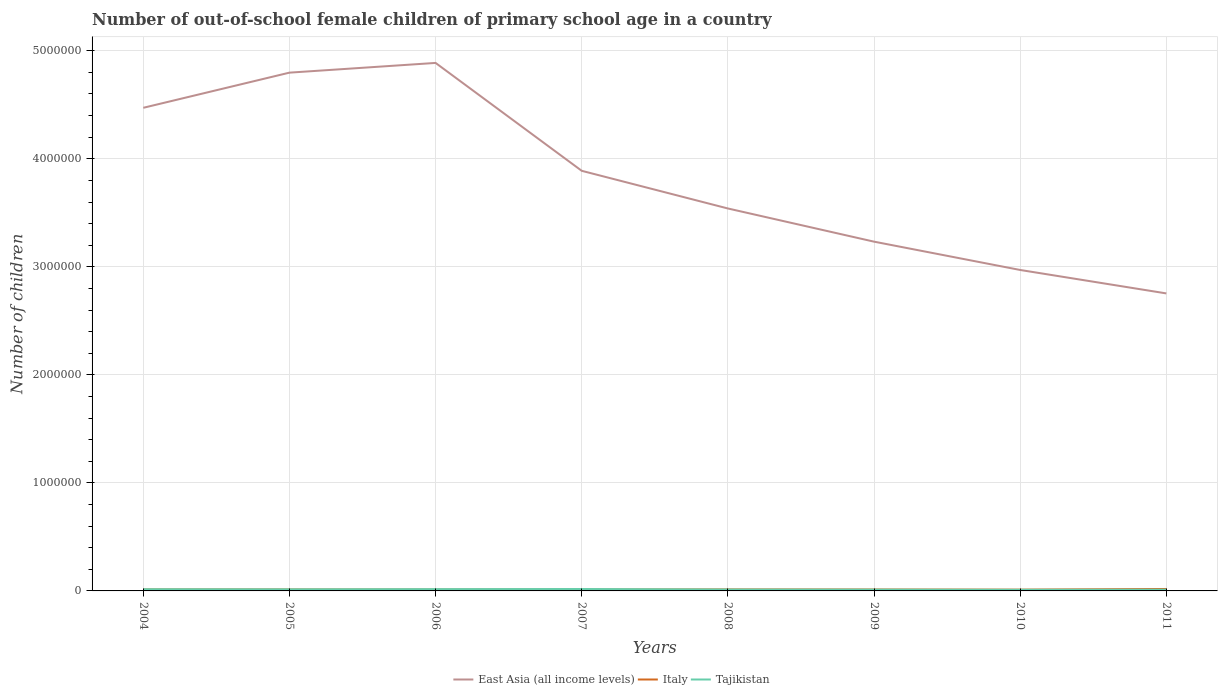How many different coloured lines are there?
Provide a short and direct response. 3. Does the line corresponding to Tajikistan intersect with the line corresponding to East Asia (all income levels)?
Your response must be concise. No. Is the number of lines equal to the number of legend labels?
Give a very brief answer. Yes. Across all years, what is the maximum number of out-of-school female children in Tajikistan?
Your answer should be very brief. 1.05e+04. What is the total number of out-of-school female children in Italy in the graph?
Give a very brief answer. 1078. What is the difference between the highest and the second highest number of out-of-school female children in Tajikistan?
Provide a short and direct response. 7159. Is the number of out-of-school female children in Italy strictly greater than the number of out-of-school female children in East Asia (all income levels) over the years?
Ensure brevity in your answer.  Yes. How many lines are there?
Your answer should be very brief. 3. How many years are there in the graph?
Your answer should be very brief. 8. What is the difference between two consecutive major ticks on the Y-axis?
Offer a very short reply. 1.00e+06. Are the values on the major ticks of Y-axis written in scientific E-notation?
Keep it short and to the point. No. Does the graph contain grids?
Provide a short and direct response. Yes. Where does the legend appear in the graph?
Provide a succinct answer. Bottom center. How many legend labels are there?
Your answer should be very brief. 3. What is the title of the graph?
Your answer should be compact. Number of out-of-school female children of primary school age in a country. What is the label or title of the X-axis?
Provide a succinct answer. Years. What is the label or title of the Y-axis?
Keep it short and to the point. Number of children. What is the Number of children of East Asia (all income levels) in 2004?
Make the answer very short. 4.47e+06. What is the Number of children of Italy in 2004?
Make the answer very short. 1.40e+04. What is the Number of children of Tajikistan in 2004?
Your answer should be very brief. 1.56e+04. What is the Number of children of East Asia (all income levels) in 2005?
Offer a terse response. 4.80e+06. What is the Number of children in Italy in 2005?
Offer a terse response. 1.37e+04. What is the Number of children of Tajikistan in 2005?
Provide a succinct answer. 1.46e+04. What is the Number of children of East Asia (all income levels) in 2006?
Your answer should be compact. 4.89e+06. What is the Number of children in Italy in 2006?
Keep it short and to the point. 1.27e+04. What is the Number of children in Tajikistan in 2006?
Make the answer very short. 1.64e+04. What is the Number of children of East Asia (all income levels) in 2007?
Offer a very short reply. 3.89e+06. What is the Number of children in Italy in 2007?
Offer a terse response. 1.31e+04. What is the Number of children in Tajikistan in 2007?
Make the answer very short. 1.77e+04. What is the Number of children of East Asia (all income levels) in 2008?
Offer a terse response. 3.54e+06. What is the Number of children of Italy in 2008?
Keep it short and to the point. 1.41e+04. What is the Number of children of Tajikistan in 2008?
Make the answer very short. 1.28e+04. What is the Number of children of East Asia (all income levels) in 2009?
Offer a terse response. 3.23e+06. What is the Number of children in Italy in 2009?
Make the answer very short. 1.33e+04. What is the Number of children of Tajikistan in 2009?
Your answer should be very brief. 1.19e+04. What is the Number of children of East Asia (all income levels) in 2010?
Your answer should be very brief. 2.97e+06. What is the Number of children of Italy in 2010?
Offer a terse response. 1.20e+04. What is the Number of children in Tajikistan in 2010?
Provide a short and direct response. 1.05e+04. What is the Number of children in East Asia (all income levels) in 2011?
Make the answer very short. 2.75e+06. What is the Number of children in Italy in 2011?
Your response must be concise. 1.79e+04. What is the Number of children in Tajikistan in 2011?
Offer a very short reply. 1.13e+04. Across all years, what is the maximum Number of children in East Asia (all income levels)?
Make the answer very short. 4.89e+06. Across all years, what is the maximum Number of children of Italy?
Offer a terse response. 1.79e+04. Across all years, what is the maximum Number of children in Tajikistan?
Provide a succinct answer. 1.77e+04. Across all years, what is the minimum Number of children in East Asia (all income levels)?
Keep it short and to the point. 2.75e+06. Across all years, what is the minimum Number of children of Italy?
Your answer should be very brief. 1.20e+04. Across all years, what is the minimum Number of children of Tajikistan?
Provide a short and direct response. 1.05e+04. What is the total Number of children in East Asia (all income levels) in the graph?
Make the answer very short. 3.05e+07. What is the total Number of children of Italy in the graph?
Make the answer very short. 1.11e+05. What is the total Number of children in Tajikistan in the graph?
Your answer should be compact. 1.11e+05. What is the difference between the Number of children of East Asia (all income levels) in 2004 and that in 2005?
Your response must be concise. -3.25e+05. What is the difference between the Number of children in Italy in 2004 and that in 2005?
Offer a very short reply. 318. What is the difference between the Number of children in Tajikistan in 2004 and that in 2005?
Your answer should be very brief. 928. What is the difference between the Number of children in East Asia (all income levels) in 2004 and that in 2006?
Provide a short and direct response. -4.15e+05. What is the difference between the Number of children in Italy in 2004 and that in 2006?
Your answer should be compact. 1282. What is the difference between the Number of children in Tajikistan in 2004 and that in 2006?
Give a very brief answer. -795. What is the difference between the Number of children in East Asia (all income levels) in 2004 and that in 2007?
Offer a terse response. 5.83e+05. What is the difference between the Number of children of Italy in 2004 and that in 2007?
Ensure brevity in your answer.  930. What is the difference between the Number of children of Tajikistan in 2004 and that in 2007?
Keep it short and to the point. -2147. What is the difference between the Number of children of East Asia (all income levels) in 2004 and that in 2008?
Make the answer very short. 9.32e+05. What is the difference between the Number of children in Italy in 2004 and that in 2008?
Make the answer very short. -48. What is the difference between the Number of children of Tajikistan in 2004 and that in 2008?
Offer a very short reply. 2710. What is the difference between the Number of children of East Asia (all income levels) in 2004 and that in 2009?
Keep it short and to the point. 1.24e+06. What is the difference between the Number of children in Italy in 2004 and that in 2009?
Provide a short and direct response. 762. What is the difference between the Number of children of Tajikistan in 2004 and that in 2009?
Provide a succinct answer. 3661. What is the difference between the Number of children of East Asia (all income levels) in 2004 and that in 2010?
Offer a terse response. 1.50e+06. What is the difference between the Number of children of Italy in 2004 and that in 2010?
Your answer should be compact. 2008. What is the difference between the Number of children in Tajikistan in 2004 and that in 2010?
Your answer should be compact. 5012. What is the difference between the Number of children in East Asia (all income levels) in 2004 and that in 2011?
Keep it short and to the point. 1.72e+06. What is the difference between the Number of children of Italy in 2004 and that in 2011?
Provide a short and direct response. -3880. What is the difference between the Number of children in Tajikistan in 2004 and that in 2011?
Keep it short and to the point. 4215. What is the difference between the Number of children in East Asia (all income levels) in 2005 and that in 2006?
Offer a very short reply. -9.01e+04. What is the difference between the Number of children of Italy in 2005 and that in 2006?
Provide a short and direct response. 964. What is the difference between the Number of children of Tajikistan in 2005 and that in 2006?
Keep it short and to the point. -1723. What is the difference between the Number of children in East Asia (all income levels) in 2005 and that in 2007?
Your answer should be very brief. 9.09e+05. What is the difference between the Number of children of Italy in 2005 and that in 2007?
Offer a terse response. 612. What is the difference between the Number of children of Tajikistan in 2005 and that in 2007?
Make the answer very short. -3075. What is the difference between the Number of children in East Asia (all income levels) in 2005 and that in 2008?
Your answer should be very brief. 1.26e+06. What is the difference between the Number of children of Italy in 2005 and that in 2008?
Provide a short and direct response. -366. What is the difference between the Number of children of Tajikistan in 2005 and that in 2008?
Your answer should be very brief. 1782. What is the difference between the Number of children of East Asia (all income levels) in 2005 and that in 2009?
Provide a succinct answer. 1.56e+06. What is the difference between the Number of children of Italy in 2005 and that in 2009?
Offer a terse response. 444. What is the difference between the Number of children in Tajikistan in 2005 and that in 2009?
Ensure brevity in your answer.  2733. What is the difference between the Number of children in East Asia (all income levels) in 2005 and that in 2010?
Provide a succinct answer. 1.83e+06. What is the difference between the Number of children of Italy in 2005 and that in 2010?
Provide a short and direct response. 1690. What is the difference between the Number of children in Tajikistan in 2005 and that in 2010?
Your response must be concise. 4084. What is the difference between the Number of children of East Asia (all income levels) in 2005 and that in 2011?
Your answer should be very brief. 2.04e+06. What is the difference between the Number of children of Italy in 2005 and that in 2011?
Give a very brief answer. -4198. What is the difference between the Number of children of Tajikistan in 2005 and that in 2011?
Offer a terse response. 3287. What is the difference between the Number of children in East Asia (all income levels) in 2006 and that in 2007?
Give a very brief answer. 9.99e+05. What is the difference between the Number of children in Italy in 2006 and that in 2007?
Keep it short and to the point. -352. What is the difference between the Number of children of Tajikistan in 2006 and that in 2007?
Give a very brief answer. -1352. What is the difference between the Number of children in East Asia (all income levels) in 2006 and that in 2008?
Your answer should be very brief. 1.35e+06. What is the difference between the Number of children in Italy in 2006 and that in 2008?
Make the answer very short. -1330. What is the difference between the Number of children of Tajikistan in 2006 and that in 2008?
Give a very brief answer. 3505. What is the difference between the Number of children of East Asia (all income levels) in 2006 and that in 2009?
Offer a terse response. 1.65e+06. What is the difference between the Number of children of Italy in 2006 and that in 2009?
Keep it short and to the point. -520. What is the difference between the Number of children of Tajikistan in 2006 and that in 2009?
Your answer should be compact. 4456. What is the difference between the Number of children in East Asia (all income levels) in 2006 and that in 2010?
Your answer should be compact. 1.92e+06. What is the difference between the Number of children of Italy in 2006 and that in 2010?
Ensure brevity in your answer.  726. What is the difference between the Number of children of Tajikistan in 2006 and that in 2010?
Offer a terse response. 5807. What is the difference between the Number of children in East Asia (all income levels) in 2006 and that in 2011?
Offer a very short reply. 2.13e+06. What is the difference between the Number of children in Italy in 2006 and that in 2011?
Provide a short and direct response. -5162. What is the difference between the Number of children of Tajikistan in 2006 and that in 2011?
Provide a succinct answer. 5010. What is the difference between the Number of children in East Asia (all income levels) in 2007 and that in 2008?
Give a very brief answer. 3.49e+05. What is the difference between the Number of children in Italy in 2007 and that in 2008?
Give a very brief answer. -978. What is the difference between the Number of children of Tajikistan in 2007 and that in 2008?
Provide a succinct answer. 4857. What is the difference between the Number of children in East Asia (all income levels) in 2007 and that in 2009?
Make the answer very short. 6.56e+05. What is the difference between the Number of children of Italy in 2007 and that in 2009?
Ensure brevity in your answer.  -168. What is the difference between the Number of children in Tajikistan in 2007 and that in 2009?
Provide a short and direct response. 5808. What is the difference between the Number of children in East Asia (all income levels) in 2007 and that in 2010?
Keep it short and to the point. 9.18e+05. What is the difference between the Number of children of Italy in 2007 and that in 2010?
Make the answer very short. 1078. What is the difference between the Number of children of Tajikistan in 2007 and that in 2010?
Your answer should be very brief. 7159. What is the difference between the Number of children in East Asia (all income levels) in 2007 and that in 2011?
Offer a very short reply. 1.13e+06. What is the difference between the Number of children of Italy in 2007 and that in 2011?
Your answer should be compact. -4810. What is the difference between the Number of children of Tajikistan in 2007 and that in 2011?
Your response must be concise. 6362. What is the difference between the Number of children of East Asia (all income levels) in 2008 and that in 2009?
Offer a very short reply. 3.07e+05. What is the difference between the Number of children of Italy in 2008 and that in 2009?
Your answer should be compact. 810. What is the difference between the Number of children of Tajikistan in 2008 and that in 2009?
Offer a terse response. 951. What is the difference between the Number of children of East Asia (all income levels) in 2008 and that in 2010?
Give a very brief answer. 5.69e+05. What is the difference between the Number of children of Italy in 2008 and that in 2010?
Your answer should be very brief. 2056. What is the difference between the Number of children of Tajikistan in 2008 and that in 2010?
Give a very brief answer. 2302. What is the difference between the Number of children in East Asia (all income levels) in 2008 and that in 2011?
Your response must be concise. 7.86e+05. What is the difference between the Number of children of Italy in 2008 and that in 2011?
Provide a succinct answer. -3832. What is the difference between the Number of children of Tajikistan in 2008 and that in 2011?
Ensure brevity in your answer.  1505. What is the difference between the Number of children of East Asia (all income levels) in 2009 and that in 2010?
Your answer should be very brief. 2.62e+05. What is the difference between the Number of children of Italy in 2009 and that in 2010?
Make the answer very short. 1246. What is the difference between the Number of children in Tajikistan in 2009 and that in 2010?
Provide a succinct answer. 1351. What is the difference between the Number of children of East Asia (all income levels) in 2009 and that in 2011?
Your answer should be very brief. 4.79e+05. What is the difference between the Number of children of Italy in 2009 and that in 2011?
Your answer should be very brief. -4642. What is the difference between the Number of children of Tajikistan in 2009 and that in 2011?
Offer a terse response. 554. What is the difference between the Number of children of East Asia (all income levels) in 2010 and that in 2011?
Provide a succinct answer. 2.17e+05. What is the difference between the Number of children of Italy in 2010 and that in 2011?
Make the answer very short. -5888. What is the difference between the Number of children of Tajikistan in 2010 and that in 2011?
Your answer should be very brief. -797. What is the difference between the Number of children in East Asia (all income levels) in 2004 and the Number of children in Italy in 2005?
Ensure brevity in your answer.  4.46e+06. What is the difference between the Number of children in East Asia (all income levels) in 2004 and the Number of children in Tajikistan in 2005?
Your response must be concise. 4.46e+06. What is the difference between the Number of children of Italy in 2004 and the Number of children of Tajikistan in 2005?
Give a very brief answer. -602. What is the difference between the Number of children of East Asia (all income levels) in 2004 and the Number of children of Italy in 2006?
Ensure brevity in your answer.  4.46e+06. What is the difference between the Number of children of East Asia (all income levels) in 2004 and the Number of children of Tajikistan in 2006?
Provide a short and direct response. 4.46e+06. What is the difference between the Number of children in Italy in 2004 and the Number of children in Tajikistan in 2006?
Offer a terse response. -2325. What is the difference between the Number of children of East Asia (all income levels) in 2004 and the Number of children of Italy in 2007?
Keep it short and to the point. 4.46e+06. What is the difference between the Number of children in East Asia (all income levels) in 2004 and the Number of children in Tajikistan in 2007?
Provide a succinct answer. 4.45e+06. What is the difference between the Number of children in Italy in 2004 and the Number of children in Tajikistan in 2007?
Offer a terse response. -3677. What is the difference between the Number of children in East Asia (all income levels) in 2004 and the Number of children in Italy in 2008?
Ensure brevity in your answer.  4.46e+06. What is the difference between the Number of children in East Asia (all income levels) in 2004 and the Number of children in Tajikistan in 2008?
Provide a short and direct response. 4.46e+06. What is the difference between the Number of children in Italy in 2004 and the Number of children in Tajikistan in 2008?
Offer a terse response. 1180. What is the difference between the Number of children in East Asia (all income levels) in 2004 and the Number of children in Italy in 2009?
Ensure brevity in your answer.  4.46e+06. What is the difference between the Number of children in East Asia (all income levels) in 2004 and the Number of children in Tajikistan in 2009?
Offer a very short reply. 4.46e+06. What is the difference between the Number of children of Italy in 2004 and the Number of children of Tajikistan in 2009?
Give a very brief answer. 2131. What is the difference between the Number of children in East Asia (all income levels) in 2004 and the Number of children in Italy in 2010?
Your answer should be very brief. 4.46e+06. What is the difference between the Number of children in East Asia (all income levels) in 2004 and the Number of children in Tajikistan in 2010?
Provide a succinct answer. 4.46e+06. What is the difference between the Number of children of Italy in 2004 and the Number of children of Tajikistan in 2010?
Your answer should be compact. 3482. What is the difference between the Number of children of East Asia (all income levels) in 2004 and the Number of children of Italy in 2011?
Provide a short and direct response. 4.45e+06. What is the difference between the Number of children in East Asia (all income levels) in 2004 and the Number of children in Tajikistan in 2011?
Keep it short and to the point. 4.46e+06. What is the difference between the Number of children in Italy in 2004 and the Number of children in Tajikistan in 2011?
Offer a terse response. 2685. What is the difference between the Number of children of East Asia (all income levels) in 2005 and the Number of children of Italy in 2006?
Your answer should be compact. 4.78e+06. What is the difference between the Number of children in East Asia (all income levels) in 2005 and the Number of children in Tajikistan in 2006?
Your answer should be compact. 4.78e+06. What is the difference between the Number of children of Italy in 2005 and the Number of children of Tajikistan in 2006?
Your answer should be very brief. -2643. What is the difference between the Number of children in East Asia (all income levels) in 2005 and the Number of children in Italy in 2007?
Provide a succinct answer. 4.78e+06. What is the difference between the Number of children in East Asia (all income levels) in 2005 and the Number of children in Tajikistan in 2007?
Make the answer very short. 4.78e+06. What is the difference between the Number of children in Italy in 2005 and the Number of children in Tajikistan in 2007?
Give a very brief answer. -3995. What is the difference between the Number of children in East Asia (all income levels) in 2005 and the Number of children in Italy in 2008?
Your answer should be compact. 4.78e+06. What is the difference between the Number of children in East Asia (all income levels) in 2005 and the Number of children in Tajikistan in 2008?
Your answer should be compact. 4.78e+06. What is the difference between the Number of children in Italy in 2005 and the Number of children in Tajikistan in 2008?
Ensure brevity in your answer.  862. What is the difference between the Number of children of East Asia (all income levels) in 2005 and the Number of children of Italy in 2009?
Your answer should be very brief. 4.78e+06. What is the difference between the Number of children in East Asia (all income levels) in 2005 and the Number of children in Tajikistan in 2009?
Give a very brief answer. 4.79e+06. What is the difference between the Number of children in Italy in 2005 and the Number of children in Tajikistan in 2009?
Your answer should be very brief. 1813. What is the difference between the Number of children in East Asia (all income levels) in 2005 and the Number of children in Italy in 2010?
Give a very brief answer. 4.79e+06. What is the difference between the Number of children of East Asia (all income levels) in 2005 and the Number of children of Tajikistan in 2010?
Give a very brief answer. 4.79e+06. What is the difference between the Number of children of Italy in 2005 and the Number of children of Tajikistan in 2010?
Ensure brevity in your answer.  3164. What is the difference between the Number of children in East Asia (all income levels) in 2005 and the Number of children in Italy in 2011?
Offer a very short reply. 4.78e+06. What is the difference between the Number of children of East Asia (all income levels) in 2005 and the Number of children of Tajikistan in 2011?
Offer a terse response. 4.79e+06. What is the difference between the Number of children in Italy in 2005 and the Number of children in Tajikistan in 2011?
Provide a short and direct response. 2367. What is the difference between the Number of children of East Asia (all income levels) in 2006 and the Number of children of Italy in 2007?
Offer a terse response. 4.87e+06. What is the difference between the Number of children in East Asia (all income levels) in 2006 and the Number of children in Tajikistan in 2007?
Your answer should be very brief. 4.87e+06. What is the difference between the Number of children of Italy in 2006 and the Number of children of Tajikistan in 2007?
Offer a very short reply. -4959. What is the difference between the Number of children of East Asia (all income levels) in 2006 and the Number of children of Italy in 2008?
Ensure brevity in your answer.  4.87e+06. What is the difference between the Number of children in East Asia (all income levels) in 2006 and the Number of children in Tajikistan in 2008?
Provide a short and direct response. 4.87e+06. What is the difference between the Number of children in Italy in 2006 and the Number of children in Tajikistan in 2008?
Provide a succinct answer. -102. What is the difference between the Number of children in East Asia (all income levels) in 2006 and the Number of children in Italy in 2009?
Your answer should be very brief. 4.87e+06. What is the difference between the Number of children in East Asia (all income levels) in 2006 and the Number of children in Tajikistan in 2009?
Offer a very short reply. 4.88e+06. What is the difference between the Number of children in Italy in 2006 and the Number of children in Tajikistan in 2009?
Make the answer very short. 849. What is the difference between the Number of children in East Asia (all income levels) in 2006 and the Number of children in Italy in 2010?
Your answer should be very brief. 4.88e+06. What is the difference between the Number of children in East Asia (all income levels) in 2006 and the Number of children in Tajikistan in 2010?
Your response must be concise. 4.88e+06. What is the difference between the Number of children in Italy in 2006 and the Number of children in Tajikistan in 2010?
Offer a terse response. 2200. What is the difference between the Number of children of East Asia (all income levels) in 2006 and the Number of children of Italy in 2011?
Your response must be concise. 4.87e+06. What is the difference between the Number of children of East Asia (all income levels) in 2006 and the Number of children of Tajikistan in 2011?
Offer a terse response. 4.88e+06. What is the difference between the Number of children in Italy in 2006 and the Number of children in Tajikistan in 2011?
Make the answer very short. 1403. What is the difference between the Number of children in East Asia (all income levels) in 2007 and the Number of children in Italy in 2008?
Offer a very short reply. 3.87e+06. What is the difference between the Number of children of East Asia (all income levels) in 2007 and the Number of children of Tajikistan in 2008?
Offer a terse response. 3.88e+06. What is the difference between the Number of children of Italy in 2007 and the Number of children of Tajikistan in 2008?
Your answer should be compact. 250. What is the difference between the Number of children of East Asia (all income levels) in 2007 and the Number of children of Italy in 2009?
Keep it short and to the point. 3.88e+06. What is the difference between the Number of children in East Asia (all income levels) in 2007 and the Number of children in Tajikistan in 2009?
Provide a succinct answer. 3.88e+06. What is the difference between the Number of children in Italy in 2007 and the Number of children in Tajikistan in 2009?
Provide a short and direct response. 1201. What is the difference between the Number of children of East Asia (all income levels) in 2007 and the Number of children of Italy in 2010?
Keep it short and to the point. 3.88e+06. What is the difference between the Number of children of East Asia (all income levels) in 2007 and the Number of children of Tajikistan in 2010?
Offer a very short reply. 3.88e+06. What is the difference between the Number of children in Italy in 2007 and the Number of children in Tajikistan in 2010?
Your answer should be compact. 2552. What is the difference between the Number of children in East Asia (all income levels) in 2007 and the Number of children in Italy in 2011?
Your answer should be compact. 3.87e+06. What is the difference between the Number of children of East Asia (all income levels) in 2007 and the Number of children of Tajikistan in 2011?
Provide a succinct answer. 3.88e+06. What is the difference between the Number of children of Italy in 2007 and the Number of children of Tajikistan in 2011?
Provide a succinct answer. 1755. What is the difference between the Number of children in East Asia (all income levels) in 2008 and the Number of children in Italy in 2009?
Offer a terse response. 3.53e+06. What is the difference between the Number of children of East Asia (all income levels) in 2008 and the Number of children of Tajikistan in 2009?
Offer a very short reply. 3.53e+06. What is the difference between the Number of children of Italy in 2008 and the Number of children of Tajikistan in 2009?
Your answer should be very brief. 2179. What is the difference between the Number of children of East Asia (all income levels) in 2008 and the Number of children of Italy in 2010?
Your answer should be compact. 3.53e+06. What is the difference between the Number of children in East Asia (all income levels) in 2008 and the Number of children in Tajikistan in 2010?
Offer a very short reply. 3.53e+06. What is the difference between the Number of children in Italy in 2008 and the Number of children in Tajikistan in 2010?
Ensure brevity in your answer.  3530. What is the difference between the Number of children in East Asia (all income levels) in 2008 and the Number of children in Italy in 2011?
Keep it short and to the point. 3.52e+06. What is the difference between the Number of children of East Asia (all income levels) in 2008 and the Number of children of Tajikistan in 2011?
Offer a very short reply. 3.53e+06. What is the difference between the Number of children in Italy in 2008 and the Number of children in Tajikistan in 2011?
Make the answer very short. 2733. What is the difference between the Number of children in East Asia (all income levels) in 2009 and the Number of children in Italy in 2010?
Make the answer very short. 3.22e+06. What is the difference between the Number of children of East Asia (all income levels) in 2009 and the Number of children of Tajikistan in 2010?
Offer a terse response. 3.22e+06. What is the difference between the Number of children in Italy in 2009 and the Number of children in Tajikistan in 2010?
Ensure brevity in your answer.  2720. What is the difference between the Number of children in East Asia (all income levels) in 2009 and the Number of children in Italy in 2011?
Your answer should be compact. 3.22e+06. What is the difference between the Number of children in East Asia (all income levels) in 2009 and the Number of children in Tajikistan in 2011?
Provide a short and direct response. 3.22e+06. What is the difference between the Number of children of Italy in 2009 and the Number of children of Tajikistan in 2011?
Provide a succinct answer. 1923. What is the difference between the Number of children in East Asia (all income levels) in 2010 and the Number of children in Italy in 2011?
Your answer should be very brief. 2.95e+06. What is the difference between the Number of children in East Asia (all income levels) in 2010 and the Number of children in Tajikistan in 2011?
Provide a short and direct response. 2.96e+06. What is the difference between the Number of children of Italy in 2010 and the Number of children of Tajikistan in 2011?
Make the answer very short. 677. What is the average Number of children of East Asia (all income levels) per year?
Make the answer very short. 3.82e+06. What is the average Number of children in Italy per year?
Keep it short and to the point. 1.39e+04. What is the average Number of children in Tajikistan per year?
Provide a short and direct response. 1.39e+04. In the year 2004, what is the difference between the Number of children of East Asia (all income levels) and Number of children of Italy?
Offer a terse response. 4.46e+06. In the year 2004, what is the difference between the Number of children in East Asia (all income levels) and Number of children in Tajikistan?
Your answer should be very brief. 4.46e+06. In the year 2004, what is the difference between the Number of children of Italy and Number of children of Tajikistan?
Give a very brief answer. -1530. In the year 2005, what is the difference between the Number of children of East Asia (all income levels) and Number of children of Italy?
Your answer should be compact. 4.78e+06. In the year 2005, what is the difference between the Number of children of East Asia (all income levels) and Number of children of Tajikistan?
Make the answer very short. 4.78e+06. In the year 2005, what is the difference between the Number of children in Italy and Number of children in Tajikistan?
Your response must be concise. -920. In the year 2006, what is the difference between the Number of children of East Asia (all income levels) and Number of children of Italy?
Make the answer very short. 4.87e+06. In the year 2006, what is the difference between the Number of children in East Asia (all income levels) and Number of children in Tajikistan?
Offer a very short reply. 4.87e+06. In the year 2006, what is the difference between the Number of children in Italy and Number of children in Tajikistan?
Keep it short and to the point. -3607. In the year 2007, what is the difference between the Number of children in East Asia (all income levels) and Number of children in Italy?
Keep it short and to the point. 3.88e+06. In the year 2007, what is the difference between the Number of children of East Asia (all income levels) and Number of children of Tajikistan?
Provide a short and direct response. 3.87e+06. In the year 2007, what is the difference between the Number of children of Italy and Number of children of Tajikistan?
Your answer should be very brief. -4607. In the year 2008, what is the difference between the Number of children of East Asia (all income levels) and Number of children of Italy?
Your answer should be compact. 3.53e+06. In the year 2008, what is the difference between the Number of children of East Asia (all income levels) and Number of children of Tajikistan?
Provide a succinct answer. 3.53e+06. In the year 2008, what is the difference between the Number of children of Italy and Number of children of Tajikistan?
Make the answer very short. 1228. In the year 2009, what is the difference between the Number of children of East Asia (all income levels) and Number of children of Italy?
Your response must be concise. 3.22e+06. In the year 2009, what is the difference between the Number of children in East Asia (all income levels) and Number of children in Tajikistan?
Your answer should be very brief. 3.22e+06. In the year 2009, what is the difference between the Number of children of Italy and Number of children of Tajikistan?
Make the answer very short. 1369. In the year 2010, what is the difference between the Number of children in East Asia (all income levels) and Number of children in Italy?
Ensure brevity in your answer.  2.96e+06. In the year 2010, what is the difference between the Number of children in East Asia (all income levels) and Number of children in Tajikistan?
Provide a short and direct response. 2.96e+06. In the year 2010, what is the difference between the Number of children in Italy and Number of children in Tajikistan?
Ensure brevity in your answer.  1474. In the year 2011, what is the difference between the Number of children in East Asia (all income levels) and Number of children in Italy?
Provide a short and direct response. 2.74e+06. In the year 2011, what is the difference between the Number of children in East Asia (all income levels) and Number of children in Tajikistan?
Offer a terse response. 2.74e+06. In the year 2011, what is the difference between the Number of children of Italy and Number of children of Tajikistan?
Keep it short and to the point. 6565. What is the ratio of the Number of children of East Asia (all income levels) in 2004 to that in 2005?
Give a very brief answer. 0.93. What is the ratio of the Number of children of Italy in 2004 to that in 2005?
Provide a short and direct response. 1.02. What is the ratio of the Number of children of Tajikistan in 2004 to that in 2005?
Provide a succinct answer. 1.06. What is the ratio of the Number of children in East Asia (all income levels) in 2004 to that in 2006?
Offer a very short reply. 0.92. What is the ratio of the Number of children of Italy in 2004 to that in 2006?
Make the answer very short. 1.1. What is the ratio of the Number of children of Tajikistan in 2004 to that in 2006?
Offer a terse response. 0.95. What is the ratio of the Number of children in East Asia (all income levels) in 2004 to that in 2007?
Make the answer very short. 1.15. What is the ratio of the Number of children in Italy in 2004 to that in 2007?
Make the answer very short. 1.07. What is the ratio of the Number of children of Tajikistan in 2004 to that in 2007?
Your answer should be very brief. 0.88. What is the ratio of the Number of children in East Asia (all income levels) in 2004 to that in 2008?
Provide a succinct answer. 1.26. What is the ratio of the Number of children of Italy in 2004 to that in 2008?
Provide a short and direct response. 1. What is the ratio of the Number of children in Tajikistan in 2004 to that in 2008?
Ensure brevity in your answer.  1.21. What is the ratio of the Number of children of East Asia (all income levels) in 2004 to that in 2009?
Offer a terse response. 1.38. What is the ratio of the Number of children of Italy in 2004 to that in 2009?
Offer a very short reply. 1.06. What is the ratio of the Number of children in Tajikistan in 2004 to that in 2009?
Your answer should be compact. 1.31. What is the ratio of the Number of children in East Asia (all income levels) in 2004 to that in 2010?
Ensure brevity in your answer.  1.51. What is the ratio of the Number of children of Italy in 2004 to that in 2010?
Keep it short and to the point. 1.17. What is the ratio of the Number of children of Tajikistan in 2004 to that in 2010?
Give a very brief answer. 1.48. What is the ratio of the Number of children of East Asia (all income levels) in 2004 to that in 2011?
Ensure brevity in your answer.  1.62. What is the ratio of the Number of children in Italy in 2004 to that in 2011?
Ensure brevity in your answer.  0.78. What is the ratio of the Number of children of Tajikistan in 2004 to that in 2011?
Keep it short and to the point. 1.37. What is the ratio of the Number of children in East Asia (all income levels) in 2005 to that in 2006?
Give a very brief answer. 0.98. What is the ratio of the Number of children in Italy in 2005 to that in 2006?
Make the answer very short. 1.08. What is the ratio of the Number of children in Tajikistan in 2005 to that in 2006?
Ensure brevity in your answer.  0.89. What is the ratio of the Number of children in East Asia (all income levels) in 2005 to that in 2007?
Give a very brief answer. 1.23. What is the ratio of the Number of children in Italy in 2005 to that in 2007?
Offer a terse response. 1.05. What is the ratio of the Number of children of Tajikistan in 2005 to that in 2007?
Give a very brief answer. 0.83. What is the ratio of the Number of children of East Asia (all income levels) in 2005 to that in 2008?
Your answer should be compact. 1.36. What is the ratio of the Number of children in Italy in 2005 to that in 2008?
Your answer should be compact. 0.97. What is the ratio of the Number of children in Tajikistan in 2005 to that in 2008?
Give a very brief answer. 1.14. What is the ratio of the Number of children of East Asia (all income levels) in 2005 to that in 2009?
Ensure brevity in your answer.  1.48. What is the ratio of the Number of children in Italy in 2005 to that in 2009?
Offer a very short reply. 1.03. What is the ratio of the Number of children of Tajikistan in 2005 to that in 2009?
Your response must be concise. 1.23. What is the ratio of the Number of children in East Asia (all income levels) in 2005 to that in 2010?
Provide a succinct answer. 1.61. What is the ratio of the Number of children in Italy in 2005 to that in 2010?
Keep it short and to the point. 1.14. What is the ratio of the Number of children of Tajikistan in 2005 to that in 2010?
Keep it short and to the point. 1.39. What is the ratio of the Number of children of East Asia (all income levels) in 2005 to that in 2011?
Make the answer very short. 1.74. What is the ratio of the Number of children in Italy in 2005 to that in 2011?
Your answer should be very brief. 0.77. What is the ratio of the Number of children in Tajikistan in 2005 to that in 2011?
Your answer should be very brief. 1.29. What is the ratio of the Number of children in East Asia (all income levels) in 2006 to that in 2007?
Your response must be concise. 1.26. What is the ratio of the Number of children of Italy in 2006 to that in 2007?
Your answer should be very brief. 0.97. What is the ratio of the Number of children of Tajikistan in 2006 to that in 2007?
Ensure brevity in your answer.  0.92. What is the ratio of the Number of children in East Asia (all income levels) in 2006 to that in 2008?
Ensure brevity in your answer.  1.38. What is the ratio of the Number of children of Italy in 2006 to that in 2008?
Your response must be concise. 0.91. What is the ratio of the Number of children of Tajikistan in 2006 to that in 2008?
Give a very brief answer. 1.27. What is the ratio of the Number of children in East Asia (all income levels) in 2006 to that in 2009?
Provide a short and direct response. 1.51. What is the ratio of the Number of children of Italy in 2006 to that in 2009?
Provide a short and direct response. 0.96. What is the ratio of the Number of children in Tajikistan in 2006 to that in 2009?
Give a very brief answer. 1.37. What is the ratio of the Number of children of East Asia (all income levels) in 2006 to that in 2010?
Offer a terse response. 1.65. What is the ratio of the Number of children of Italy in 2006 to that in 2010?
Provide a succinct answer. 1.06. What is the ratio of the Number of children in Tajikistan in 2006 to that in 2010?
Give a very brief answer. 1.55. What is the ratio of the Number of children of East Asia (all income levels) in 2006 to that in 2011?
Keep it short and to the point. 1.77. What is the ratio of the Number of children of Italy in 2006 to that in 2011?
Offer a very short reply. 0.71. What is the ratio of the Number of children of Tajikistan in 2006 to that in 2011?
Your answer should be very brief. 1.44. What is the ratio of the Number of children of East Asia (all income levels) in 2007 to that in 2008?
Ensure brevity in your answer.  1.1. What is the ratio of the Number of children of Italy in 2007 to that in 2008?
Provide a succinct answer. 0.93. What is the ratio of the Number of children in Tajikistan in 2007 to that in 2008?
Your answer should be very brief. 1.38. What is the ratio of the Number of children of East Asia (all income levels) in 2007 to that in 2009?
Offer a terse response. 1.2. What is the ratio of the Number of children of Italy in 2007 to that in 2009?
Your response must be concise. 0.99. What is the ratio of the Number of children of Tajikistan in 2007 to that in 2009?
Ensure brevity in your answer.  1.49. What is the ratio of the Number of children of East Asia (all income levels) in 2007 to that in 2010?
Make the answer very short. 1.31. What is the ratio of the Number of children in Italy in 2007 to that in 2010?
Your answer should be compact. 1.09. What is the ratio of the Number of children of Tajikistan in 2007 to that in 2010?
Your answer should be compact. 1.68. What is the ratio of the Number of children in East Asia (all income levels) in 2007 to that in 2011?
Make the answer very short. 1.41. What is the ratio of the Number of children of Italy in 2007 to that in 2011?
Make the answer very short. 0.73. What is the ratio of the Number of children in Tajikistan in 2007 to that in 2011?
Your response must be concise. 1.56. What is the ratio of the Number of children in East Asia (all income levels) in 2008 to that in 2009?
Your response must be concise. 1.09. What is the ratio of the Number of children in Italy in 2008 to that in 2009?
Make the answer very short. 1.06. What is the ratio of the Number of children in Tajikistan in 2008 to that in 2009?
Provide a short and direct response. 1.08. What is the ratio of the Number of children in East Asia (all income levels) in 2008 to that in 2010?
Make the answer very short. 1.19. What is the ratio of the Number of children in Italy in 2008 to that in 2010?
Offer a terse response. 1.17. What is the ratio of the Number of children of Tajikistan in 2008 to that in 2010?
Offer a terse response. 1.22. What is the ratio of the Number of children of East Asia (all income levels) in 2008 to that in 2011?
Provide a succinct answer. 1.29. What is the ratio of the Number of children of Italy in 2008 to that in 2011?
Give a very brief answer. 0.79. What is the ratio of the Number of children in Tajikistan in 2008 to that in 2011?
Ensure brevity in your answer.  1.13. What is the ratio of the Number of children in East Asia (all income levels) in 2009 to that in 2010?
Keep it short and to the point. 1.09. What is the ratio of the Number of children in Italy in 2009 to that in 2010?
Offer a terse response. 1.1. What is the ratio of the Number of children of Tajikistan in 2009 to that in 2010?
Make the answer very short. 1.13. What is the ratio of the Number of children in East Asia (all income levels) in 2009 to that in 2011?
Your answer should be very brief. 1.17. What is the ratio of the Number of children in Italy in 2009 to that in 2011?
Keep it short and to the point. 0.74. What is the ratio of the Number of children of Tajikistan in 2009 to that in 2011?
Your answer should be very brief. 1.05. What is the ratio of the Number of children of East Asia (all income levels) in 2010 to that in 2011?
Give a very brief answer. 1.08. What is the ratio of the Number of children of Italy in 2010 to that in 2011?
Your answer should be very brief. 0.67. What is the ratio of the Number of children of Tajikistan in 2010 to that in 2011?
Provide a succinct answer. 0.93. What is the difference between the highest and the second highest Number of children in East Asia (all income levels)?
Offer a terse response. 9.01e+04. What is the difference between the highest and the second highest Number of children in Italy?
Your answer should be compact. 3832. What is the difference between the highest and the second highest Number of children of Tajikistan?
Offer a terse response. 1352. What is the difference between the highest and the lowest Number of children in East Asia (all income levels)?
Your answer should be compact. 2.13e+06. What is the difference between the highest and the lowest Number of children of Italy?
Keep it short and to the point. 5888. What is the difference between the highest and the lowest Number of children in Tajikistan?
Keep it short and to the point. 7159. 